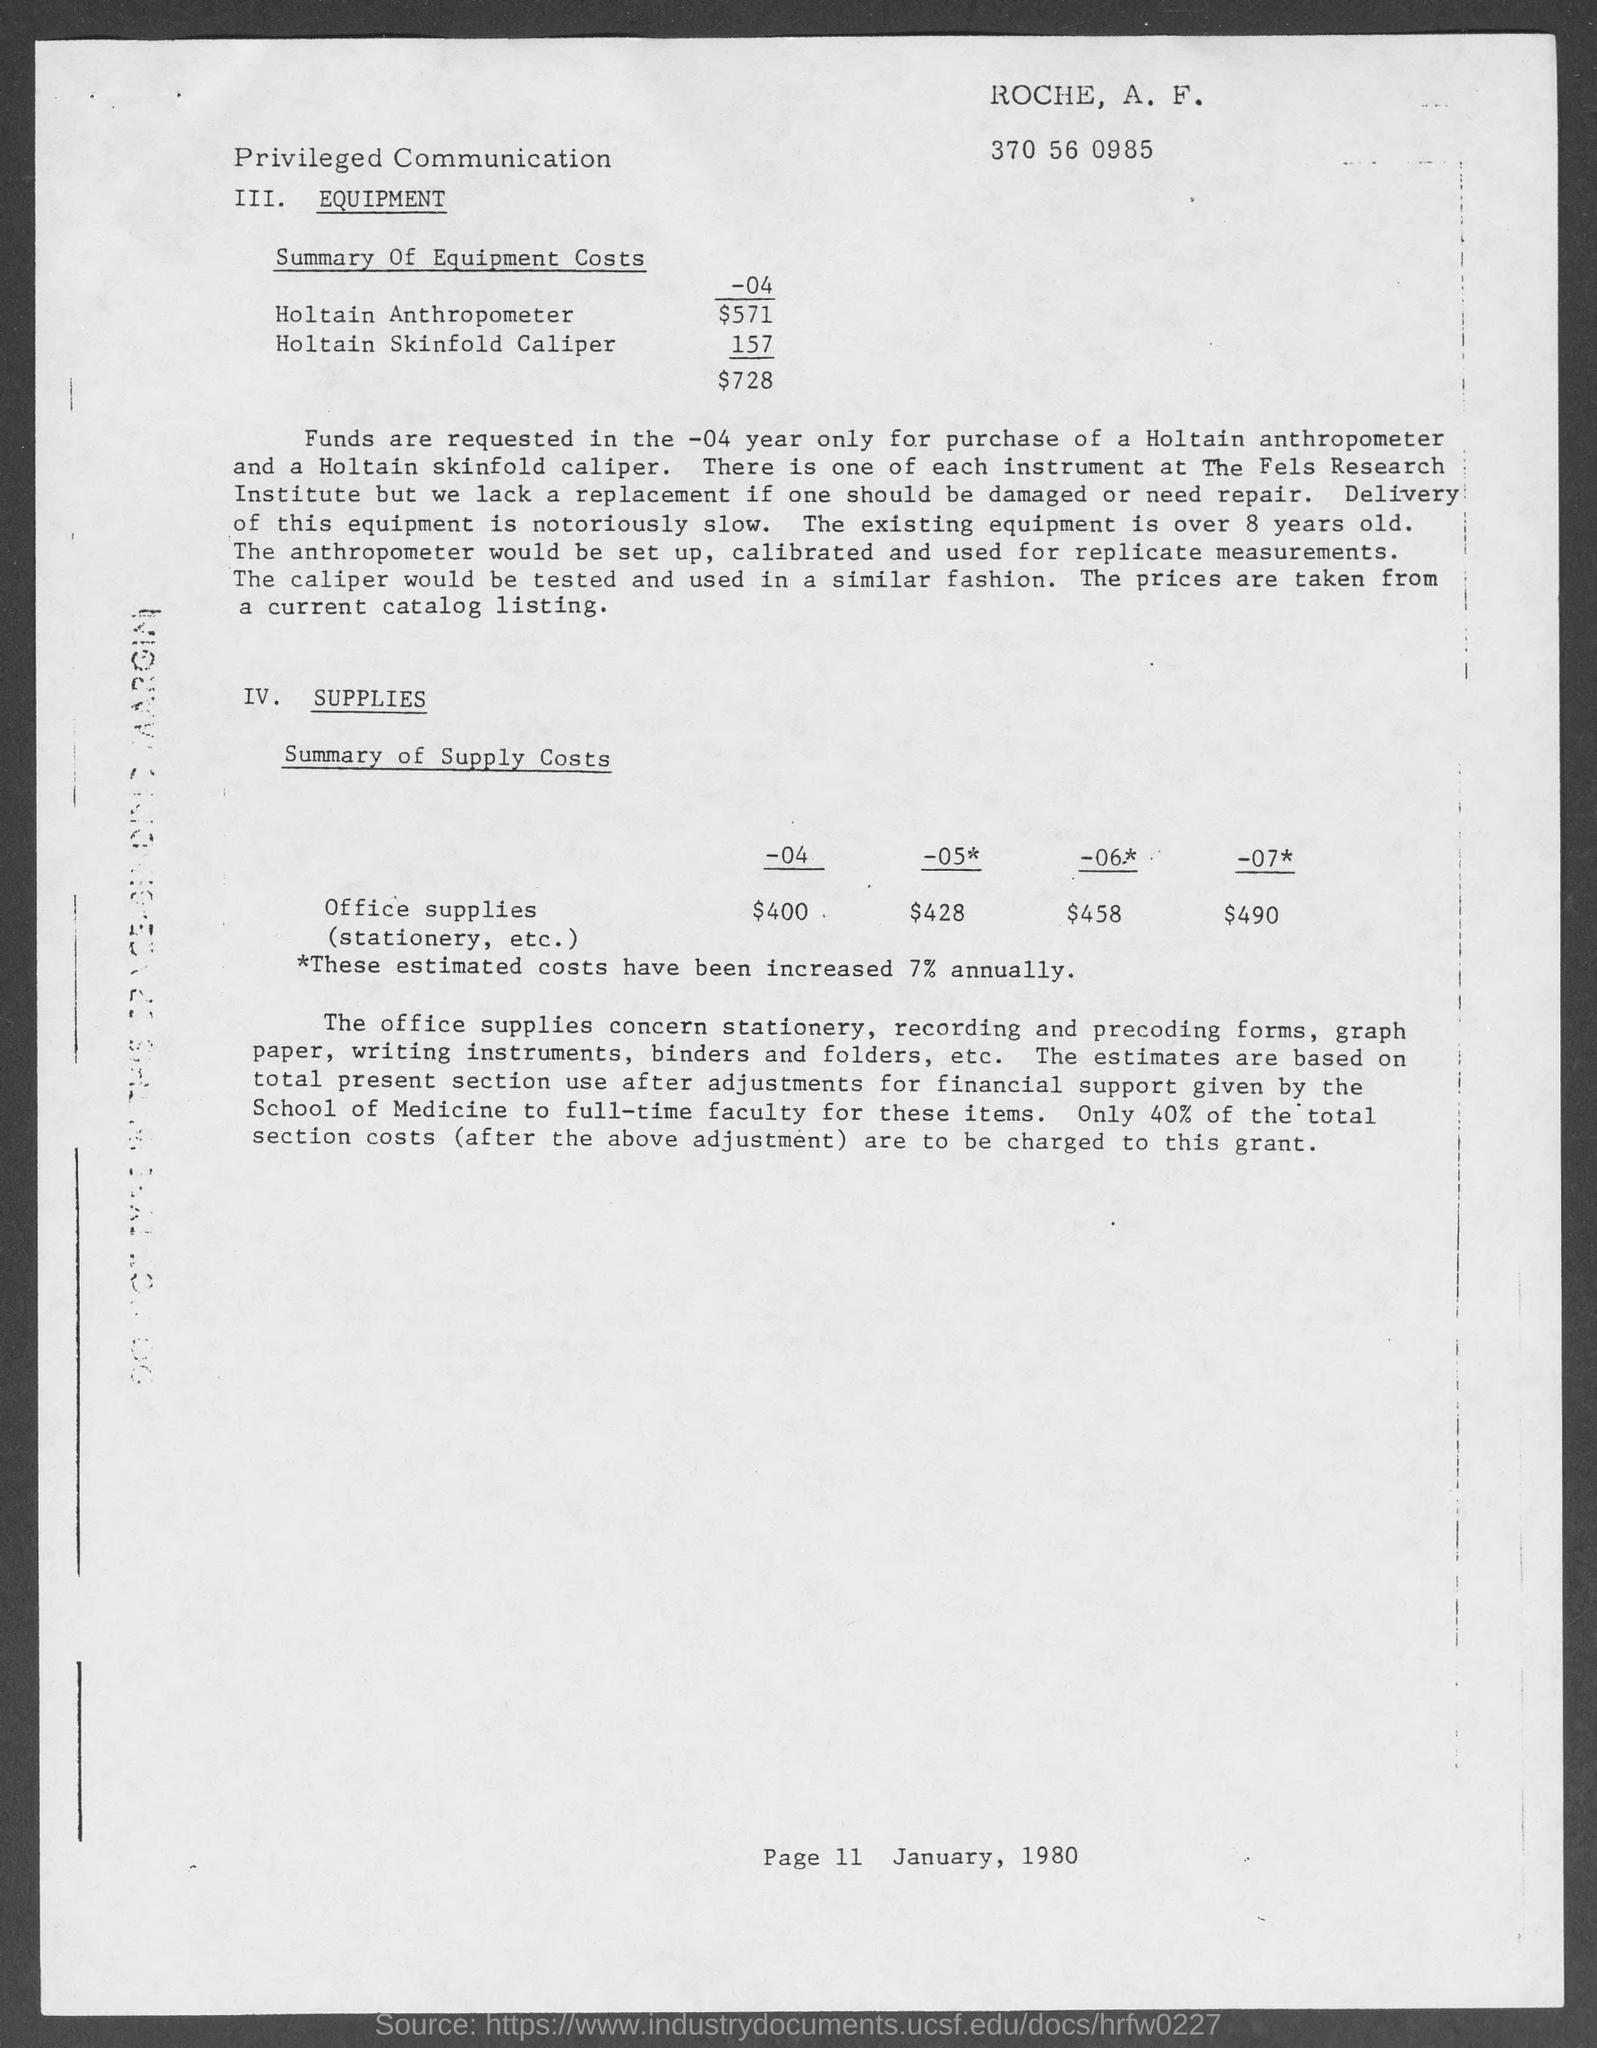Indicate a few pertinent items in this graphic. The page number mentioned in this document is 11. The date mentioned in the document is January, 1980. The office supplies costs for the year 2007 were $490. The office supplies expenses for the year 2004 were $400. The office supplies costs for the year 2005 were $428. 